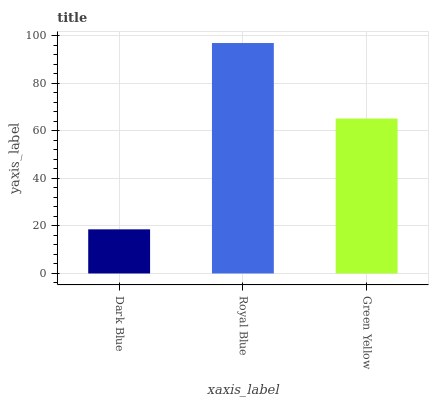Is Green Yellow the minimum?
Answer yes or no. No. Is Green Yellow the maximum?
Answer yes or no. No. Is Royal Blue greater than Green Yellow?
Answer yes or no. Yes. Is Green Yellow less than Royal Blue?
Answer yes or no. Yes. Is Green Yellow greater than Royal Blue?
Answer yes or no. No. Is Royal Blue less than Green Yellow?
Answer yes or no. No. Is Green Yellow the high median?
Answer yes or no. Yes. Is Green Yellow the low median?
Answer yes or no. Yes. Is Dark Blue the high median?
Answer yes or no. No. Is Royal Blue the low median?
Answer yes or no. No. 